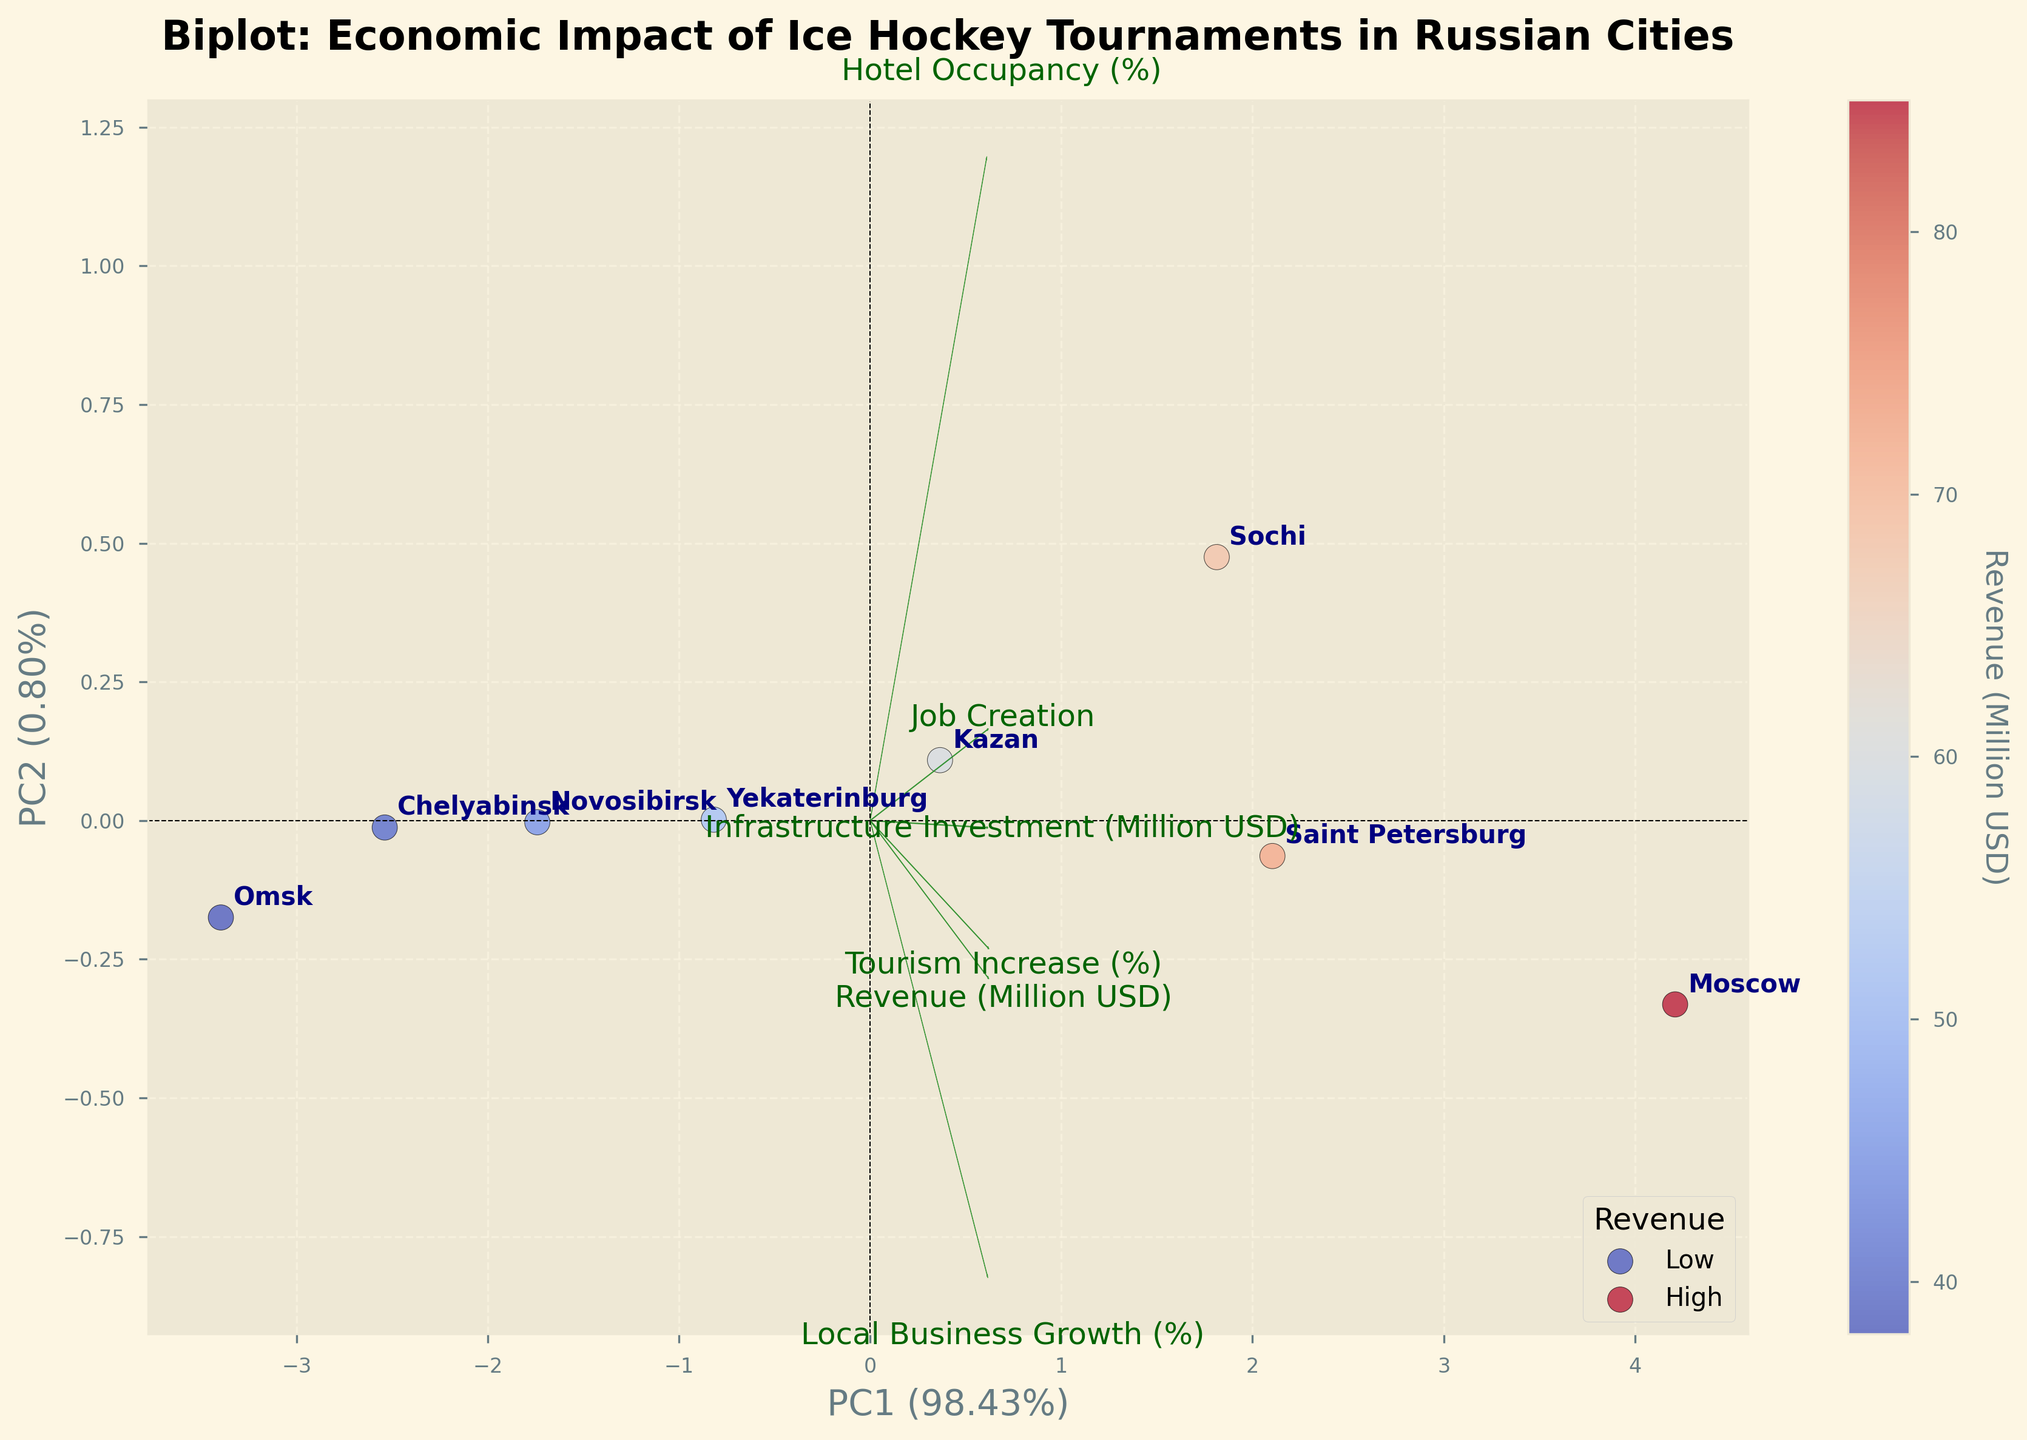what are the two principal components shown on the axes? The two principal components are shown on the x-axis and y-axis. The x-axis represents PC1, while the y-axis represents PC2. The percentages in the axis labels indicate the explained variance for each component: PC1 and PC2.
Answer: PC1 and PC2 Which city is labeled the farthest right on the biplot? The farthest right label on the biplot is Moscow. The positions of the city labels help identify their locations.
Answer: Moscow Which feature has the longest vector in the biplot? The feature with the longest vector in the biplot is the one with the arrow extending the farthest from the origin. On this biplot, "Hotel Occupancy (%)" appears to have the longest vector.
Answer: Hotel Occupancy (%) What does the color gradient of the scatter points represent? The color gradient of the scatter points represents the "Revenue (Million USD)" for each city. The colorbar indicates the mapping of color to revenue values, with a gradient from cool to warm colors.
Answer: Revenue (Million USD) Which city shows the highest hotel occupancy rate? By comparing the directions of the vectors and the positions of the cities, the city closest aligned with the "Hotel Occupancy (%)" vector with high positioning is Sochi.
Answer: Sochi How many cities are shown in the biplot? The number of data points in the biplot corresponds to the number of cities. Counting the city labels in the biplot, there are 8 cities shown.
Answer: 8 Between Kazan and Yekaterinburg, which city has lower job creation? By observing the positions of Kazan and Yekaterinburg concerning the "Job Creation" vector, Kazan is positioned lower, indicating it has lower job creation compared to Yekaterinburg.
Answer: Kazan What is the relationship between "Revenue (Million USD)" and "Tourism Increase (%)"? To understand the relationship, observe the angles between their vectors. Both vectors point in relatively similar directions suggesting a positive correlation, meaning as revenue increases, tourism increase likely follows.
Answer: Positive correlation Which city benefited the most from local business growth? By observing the direction of the "Local Business Growth (%)" vector and the city positions, Moscow is positioned closest to this vector, indicating it saw the most benefit in local business growth.
Answer: Moscow What can be inferred about Chelyabinsk's infrastructure investment? Chelyabinsk is positioned lower on the plot and closer to the origin compared to other cities concerning the "Infrastructure Investment (Million USD)" vector, indicating it received relatively lower infrastructure investment.
Answer: Lower investment 